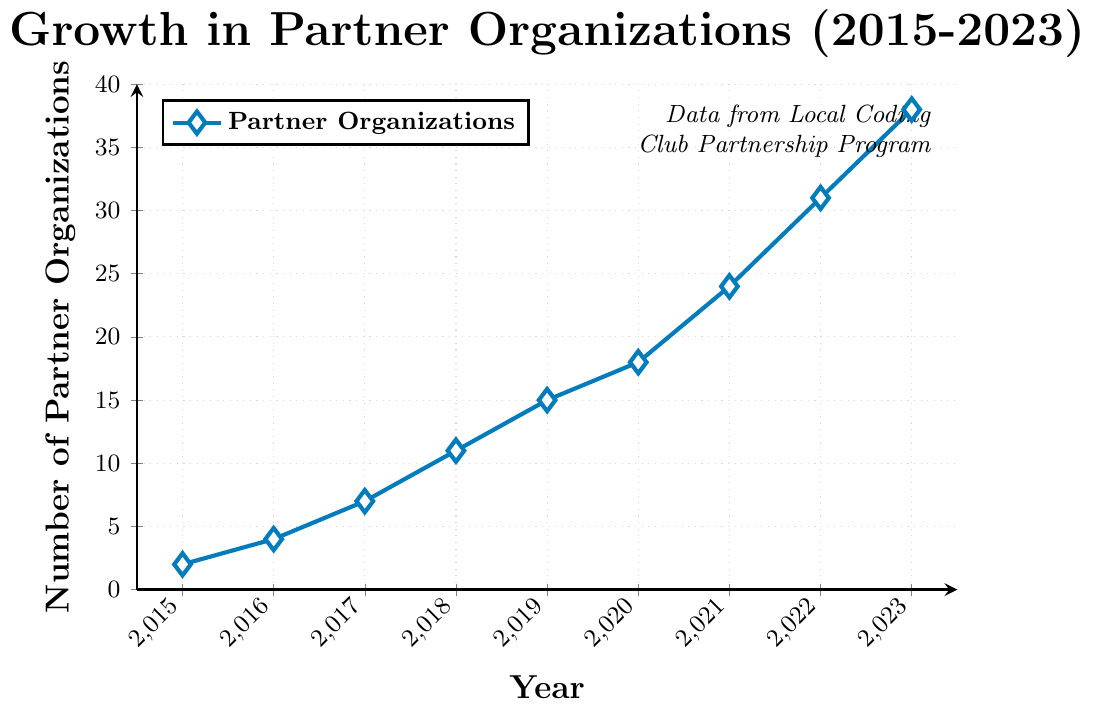What's the total increase in the number of partner organizations from 2015 to 2023? Note the number of partner organizations in 2015 (2) and in 2023 (38). Subtracting the two, 38 - 2, gives the total increase.
Answer: 36 Which year saw the highest number of new partner organizations joining? Calculate the yearly increase: 2016 (4-2=2), 2017 (7-4=3), 2018 (11-7=4), 2019 (15-11=4), 2020 (18-15=3), 2021 (24-18=6), 2022 (31-24=7), 2023 (38-31=7). The year 2022 and 2023 both have the highest increase of 7.
Answer: 2022 and 2023 What is the average annual increase in the number of partner organizations from 2015 to 2023? First, find the total increase from 2015 to 2023, which is 36. There are 8 intervals (2023-2015). Divide the total increase by the number of intervals: 36 / 8 = 4.5.
Answer: 4.5 How many years did it take to reach more than 20 partner organizations? Starting from 2015 with 2 partners, check each year until the number exceeds 20 in 2021 with 24 partners. Counting the years from 2015 to 2021 gives 6 years.
Answer: 6 Between which consecutive years was the number of partner organizations equal? Review the data: consecutive years always see a change in the number of partner organizations, so no consecutive years have equal numbers.
Answer: None How does the growth trend appear visually in the chart? Observing the trend in the line chart, it shows a consistent upward slope with a slightly accelerating increase towards the end.
Answer: Consistent upward slope What is the percentage increase in partner organizations from 2019 to 2023? Calculate the number of partner organizations in 2019 (15) and 2023 (38). The increase is 38 - 15 = 23. The percentage increase is (23/15) * 100 ≈ 153.33%.
Answer: 153.33% Did the club ever experience a decrease in the number of partner organizations year over year? Observing the consistent upward trajectory in the chart, it is clear there was no year-over-year decrease.
Answer: No What is the proportion of the number of partner organizations in 2020 compared to 2023? The number of partner organizations in 2020 is 18 and in 2023 it is 38. The proportion is 18/38 ≈ 0.474.
Answer: 0.474 What can be inferred about the future trend if the current growth rate continues? Based on the consistent positive growth and even accelerating rate in recent years, if the trend continues, the number of partner organizations is likely to keep growing steadily.
Answer: Continued growth 